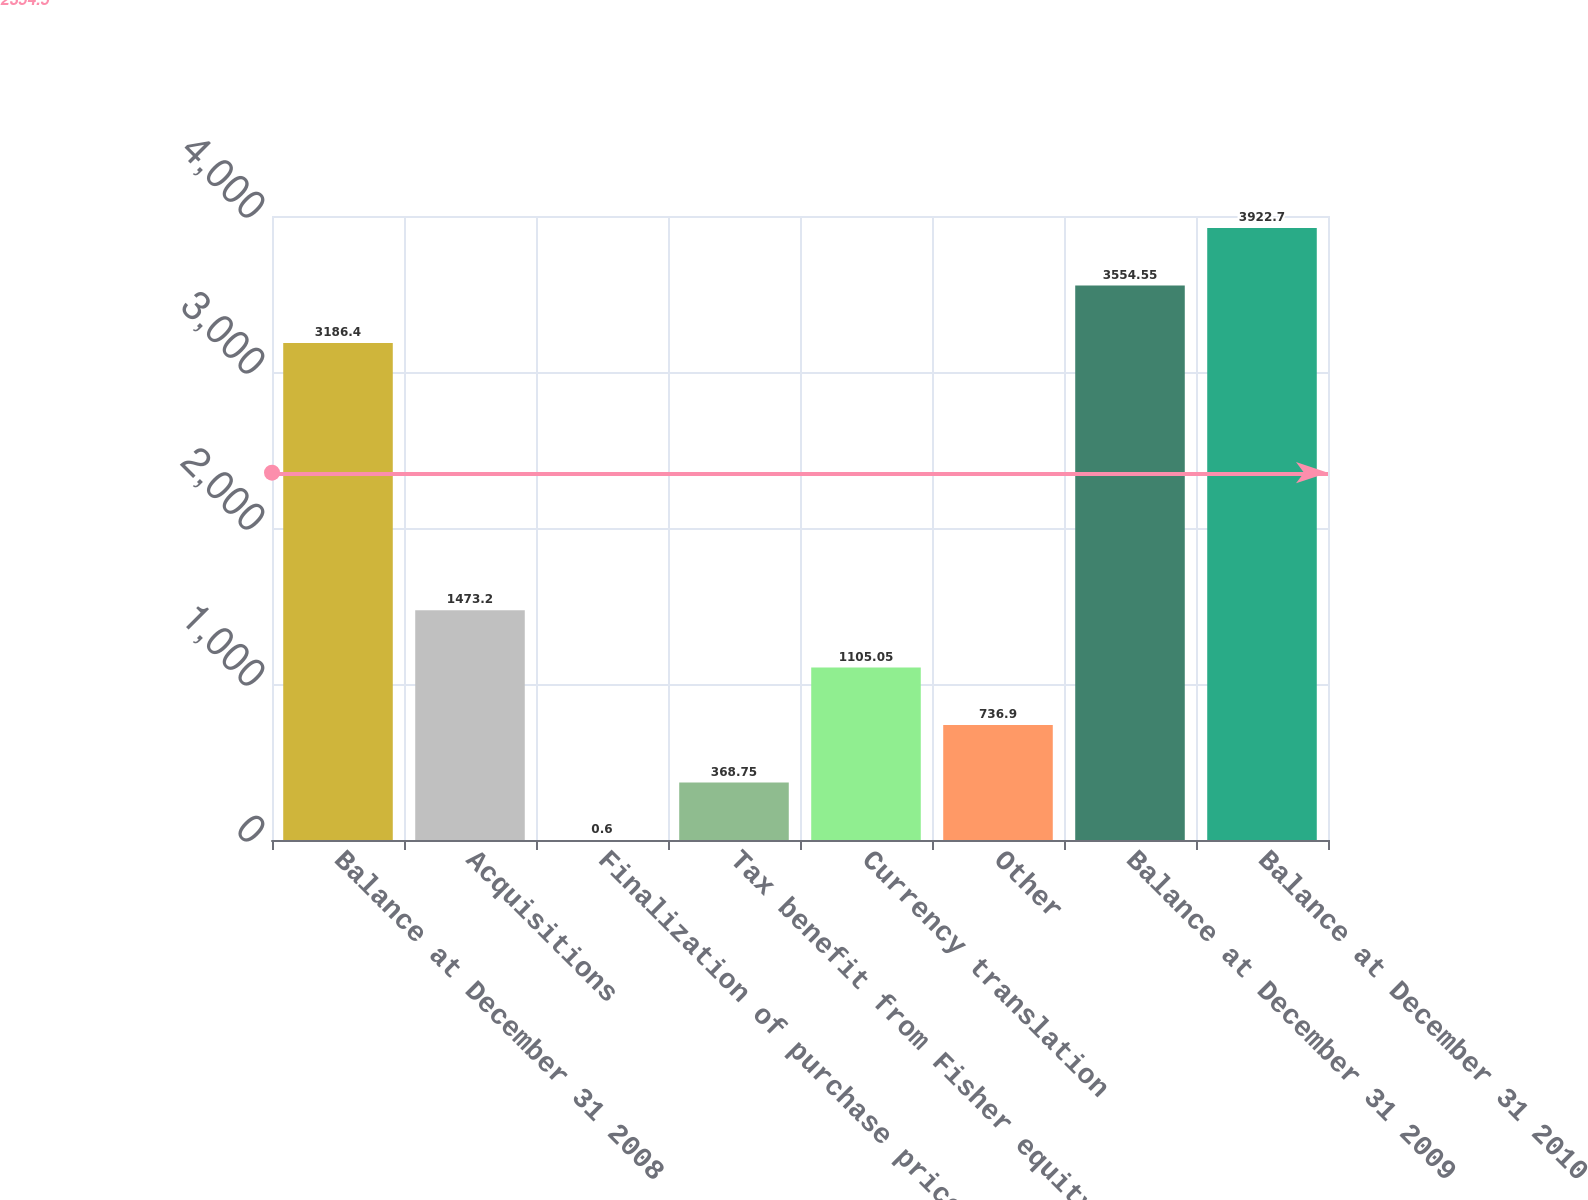Convert chart to OTSL. <chart><loc_0><loc_0><loc_500><loc_500><bar_chart><fcel>Balance at December 31 2008<fcel>Acquisitions<fcel>Finalization of purchase price<fcel>Tax benefit from Fisher equity<fcel>Currency translation<fcel>Other<fcel>Balance at December 31 2009<fcel>Balance at December 31 2010<nl><fcel>3186.4<fcel>1473.2<fcel>0.6<fcel>368.75<fcel>1105.05<fcel>736.9<fcel>3554.55<fcel>3922.7<nl></chart> 